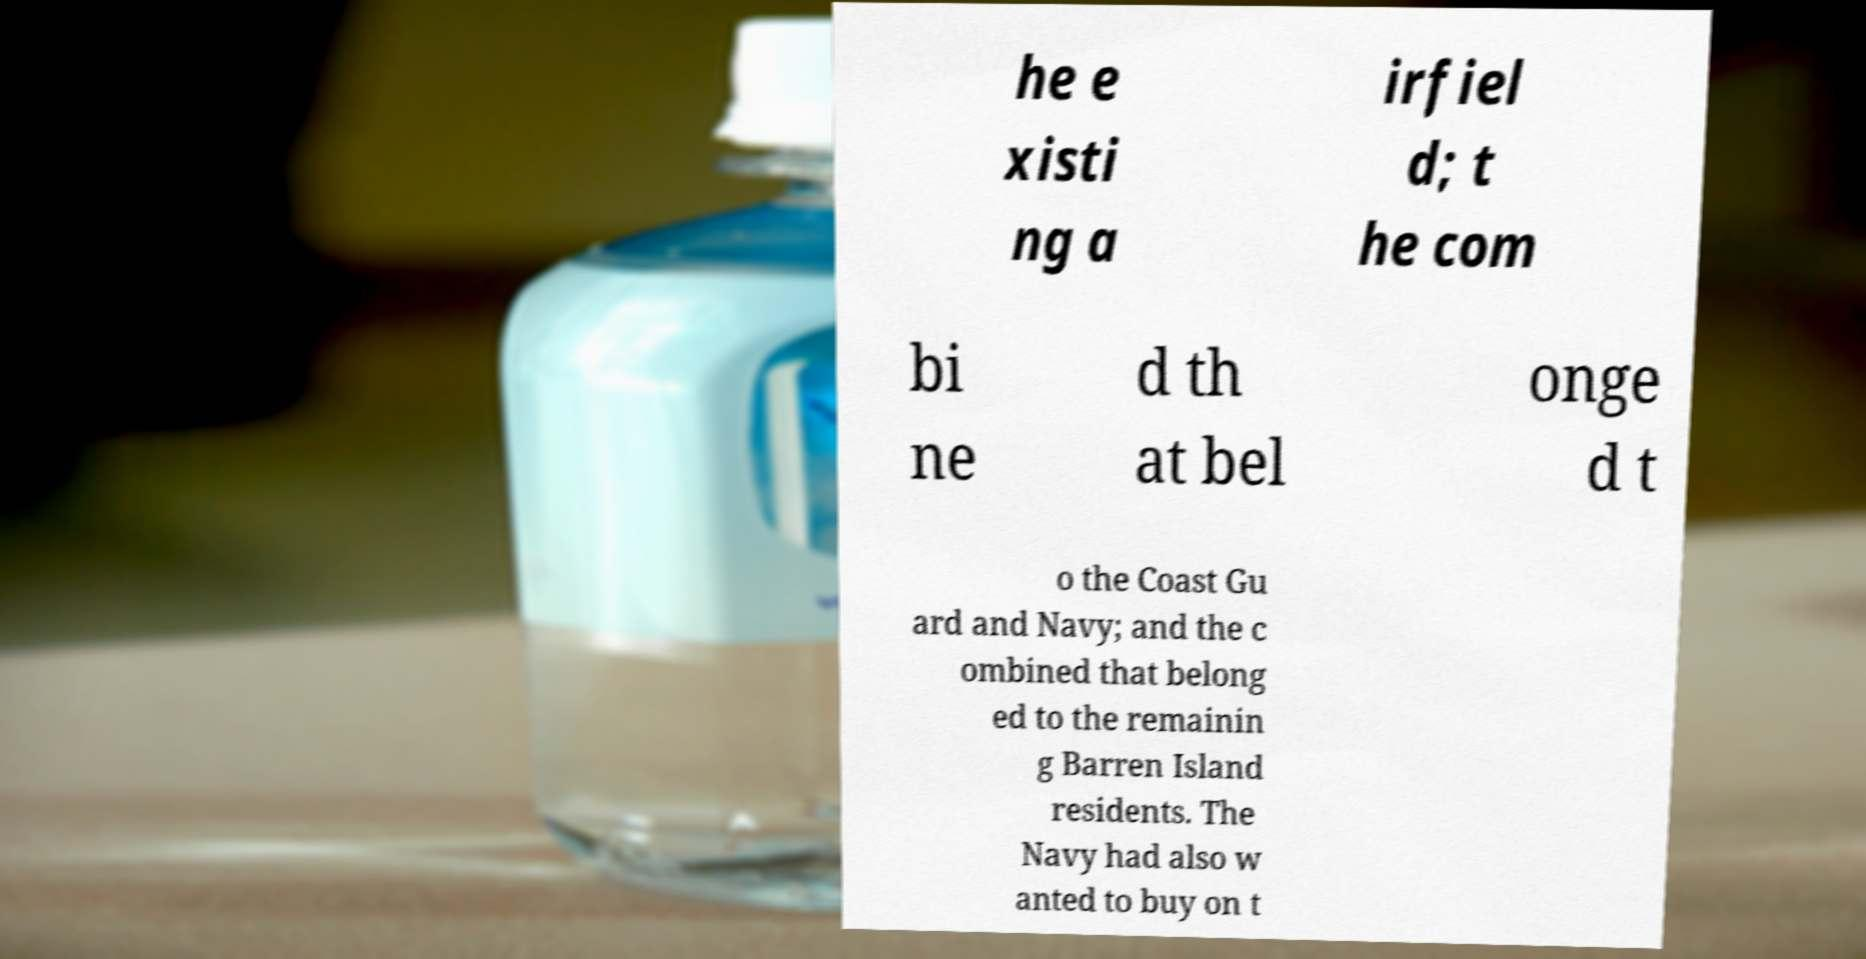Can you accurately transcribe the text from the provided image for me? he e xisti ng a irfiel d; t he com bi ne d th at bel onge d t o the Coast Gu ard and Navy; and the c ombined that belong ed to the remainin g Barren Island residents. The Navy had also w anted to buy on t 